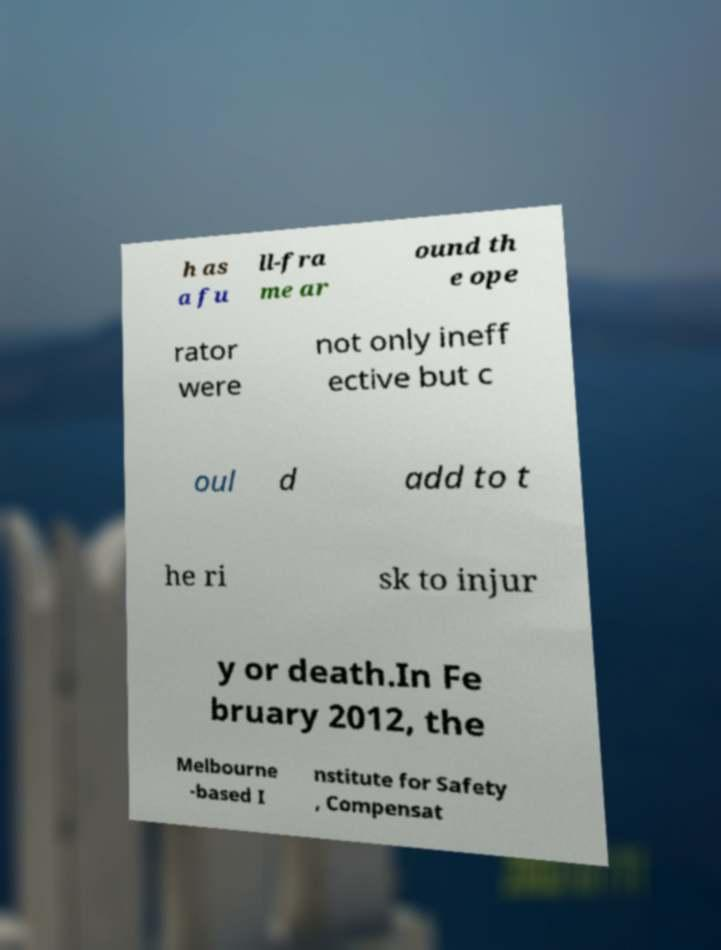I need the written content from this picture converted into text. Can you do that? h as a fu ll-fra me ar ound th e ope rator were not only ineff ective but c oul d add to t he ri sk to injur y or death.In Fe bruary 2012, the Melbourne -based I nstitute for Safety , Compensat 